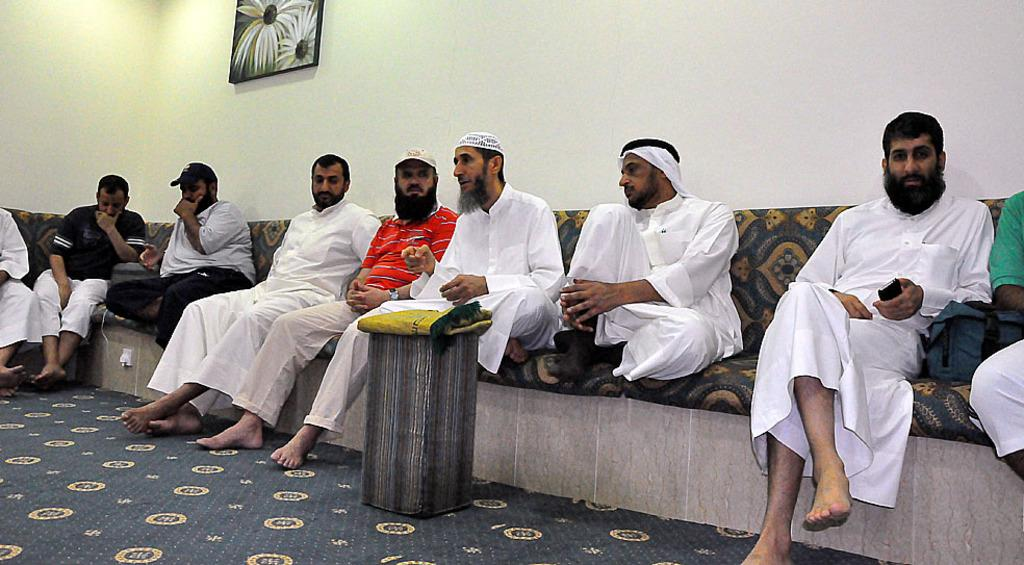What is the main subject of the image? The main subject of the image is a group of people. What are the people in the image doing? The people are seated. Can you describe any specific clothing or accessories worn by the people in the image? Some people in the group are wearing caps. What can be seen in the background of the image? There is a frame on the wall in the background of the image. What type of wren can be seen perched on the frame in the image? There is no wren present in the image; the background only features a frame on the wall. What kind of brush is being used by the people in the image? There is no brush visible in the image; the people are simply seated. 